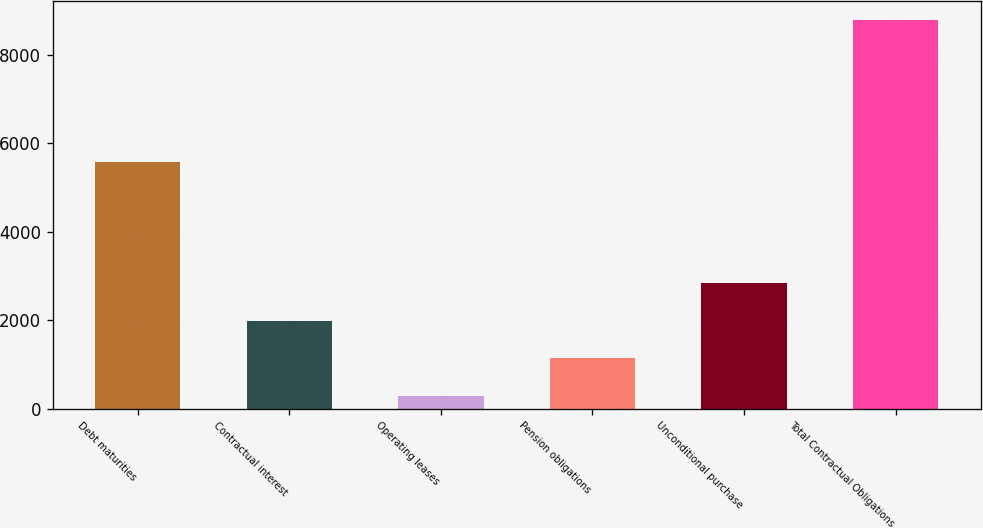Convert chart to OTSL. <chart><loc_0><loc_0><loc_500><loc_500><bar_chart><fcel>Debt maturities<fcel>Contractual interest<fcel>Operating leases<fcel>Pension obligations<fcel>Unconditional purchase<fcel>Total Contractual Obligations<nl><fcel>5564<fcel>1984.2<fcel>286<fcel>1135.1<fcel>2833.3<fcel>8777<nl></chart> 